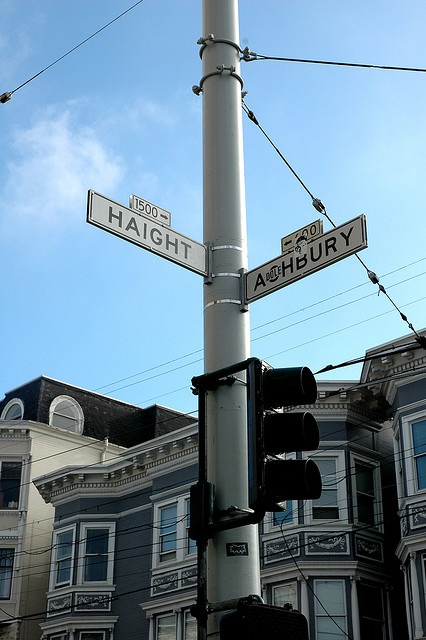Describe the objects in this image and their specific colors. I can see traffic light in lightblue, black, gray, navy, and darkgray tones and traffic light in lightblue, black, purple, and darkblue tones in this image. 